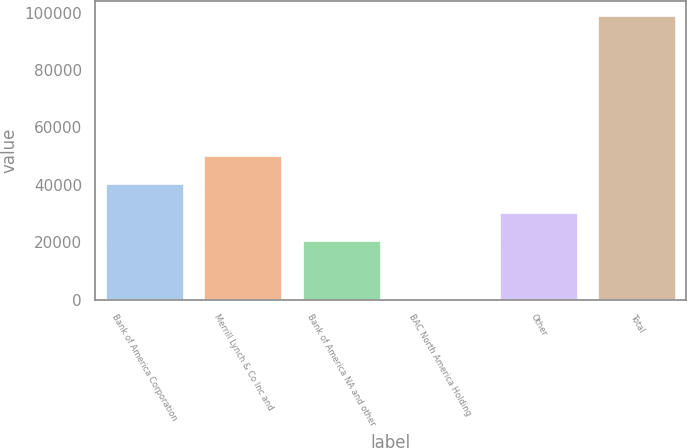Convert chart. <chart><loc_0><loc_0><loc_500><loc_500><bar_chart><fcel>Bank of America Corporation<fcel>Merrill Lynch & Co Inc and<fcel>Bank of America NA and other<fcel>BAC North America Holding<fcel>Other<fcel>Total<nl><fcel>40593<fcel>50500<fcel>20779<fcel>74<fcel>30686<fcel>99144<nl></chart> 